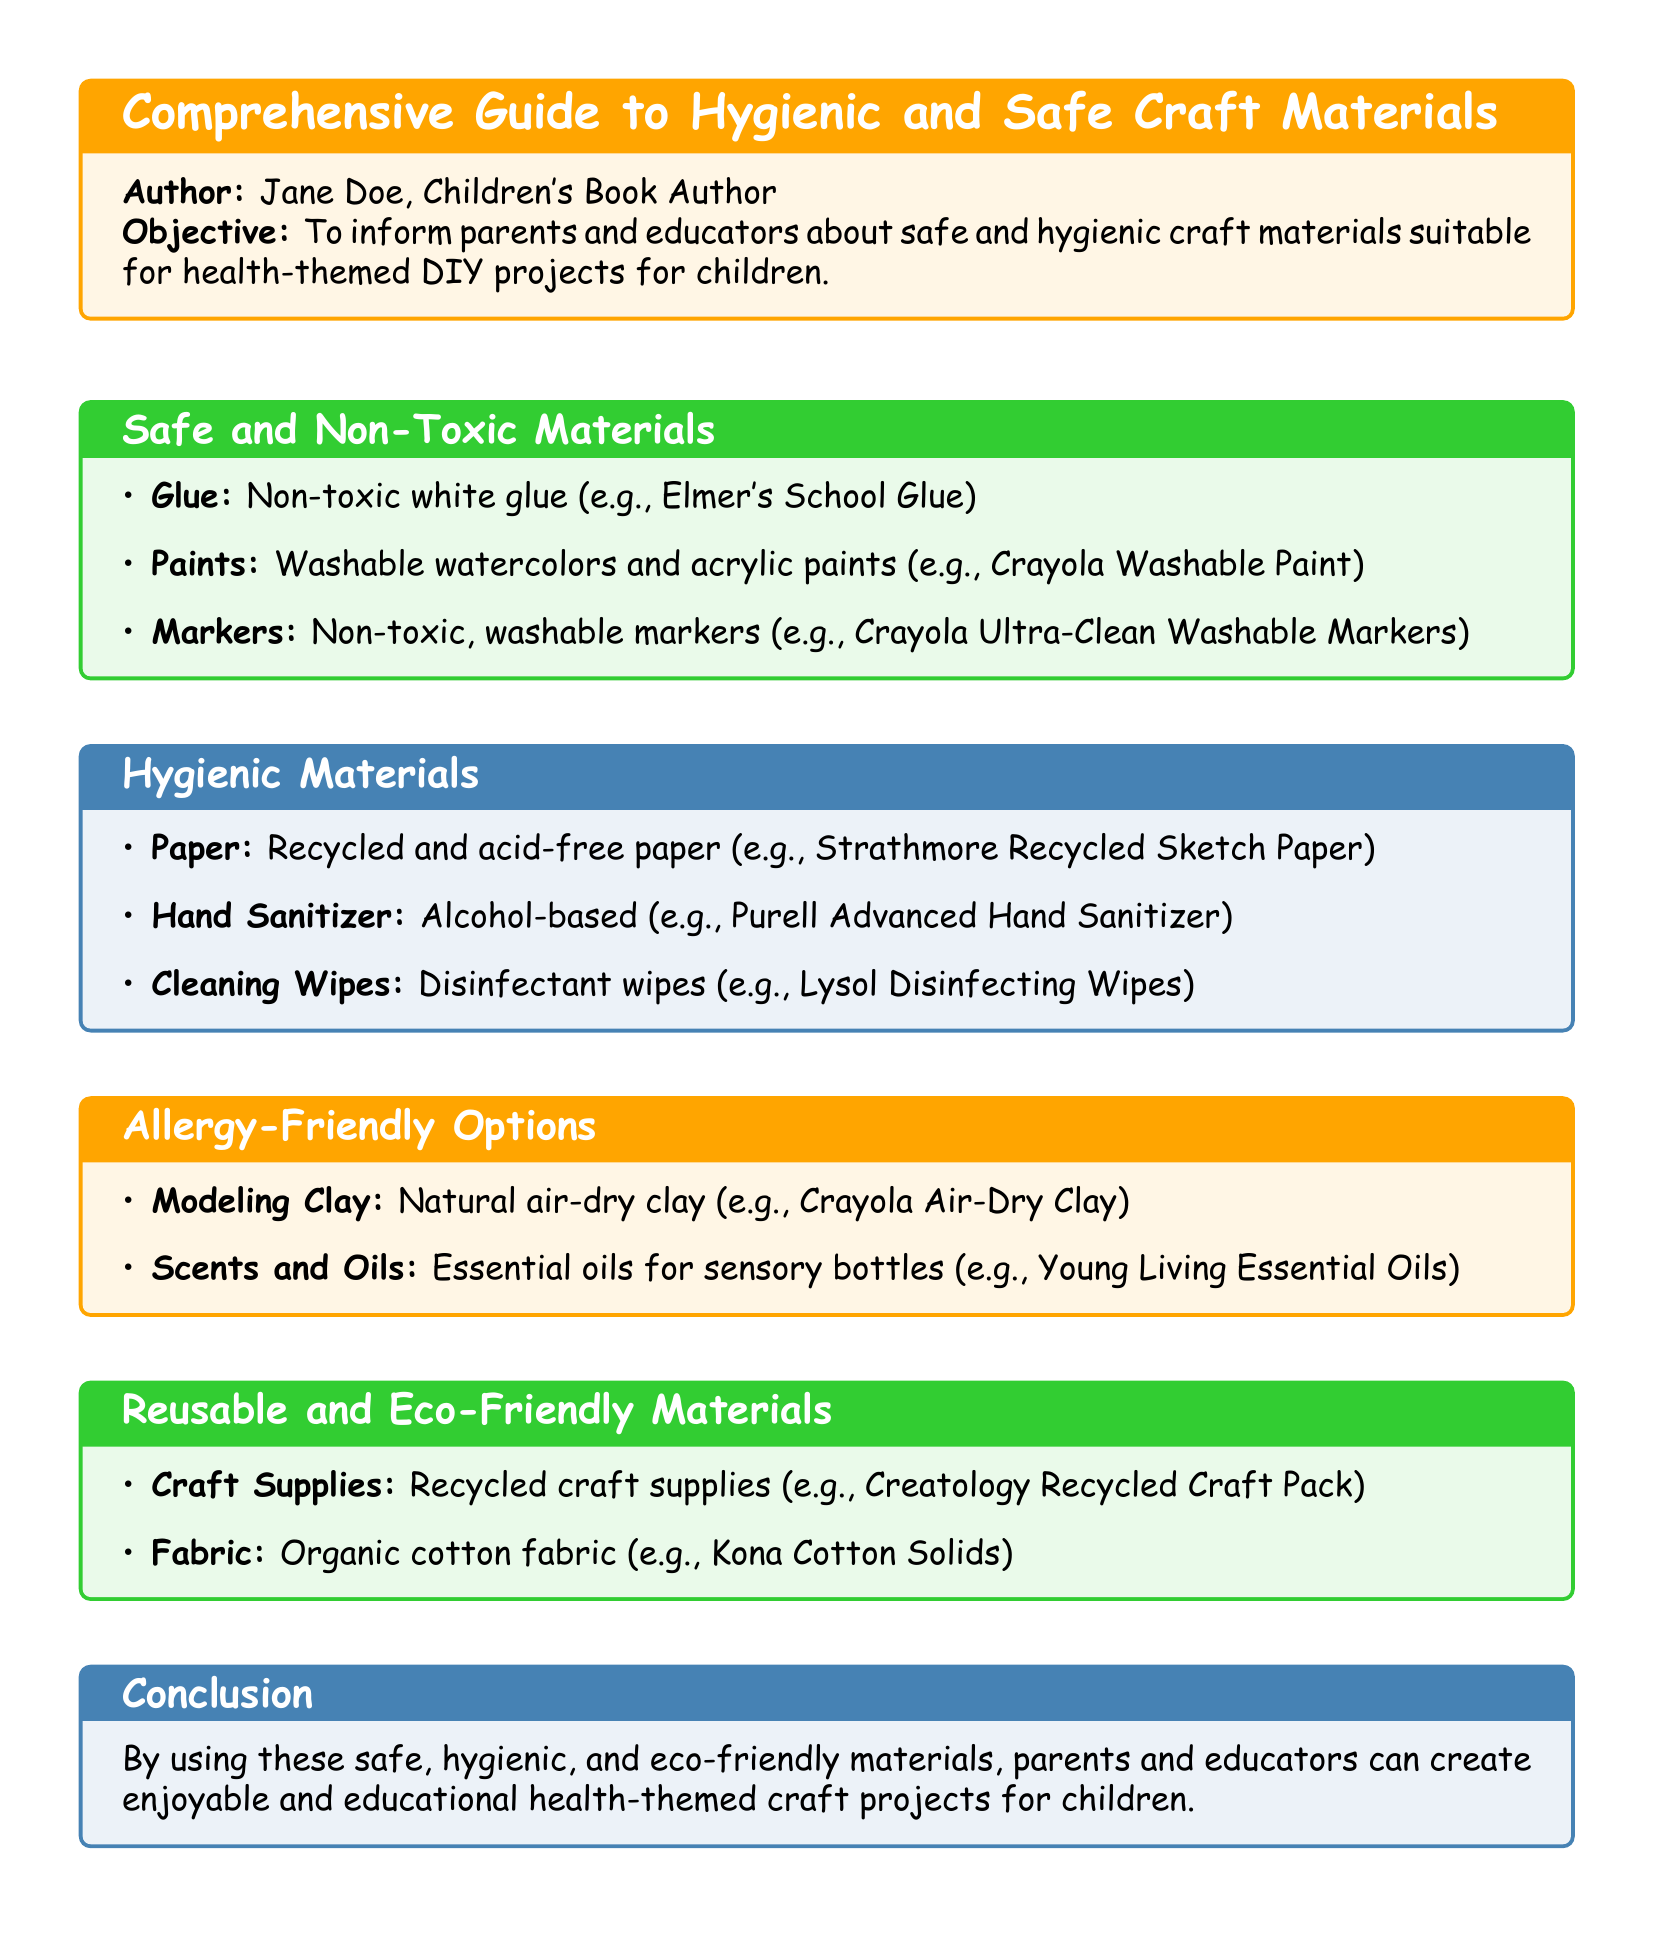What is the author's name? The author's name is presented in the document as part of the title box.
Answer: Jane Doe What type of glue is recommended? The specific type of glue is mentioned under the safe materials section of the document.
Answer: Non-toxic white glue What color is used for the hygiene materials section title? The color specified for the hygiene materials section title is listed in the document.
Answer: Kid blue What is one example of a reusable and eco-friendly material? The examples of reusable materials are listed in the eco-friendly section.
Answer: Organic cotton fabric How many categories of materials are mentioned in the document? The document includes multiple sections, each representing a category of materials.
Answer: Four What is the recommended hand sanitizer? The specific hand sanitizer type is provided under the hygienic materials section.
Answer: Alcohol-based Which product is suggested for modeling clay? The document lists a specific modeling clay under the allergy-friendly options section.
Answer: Natural air-dry clay What kind of fabric is mentioned as eco-friendly? The eco-friendly materials section details the type of fabric recommended.
Answer: Organic cotton fabric 